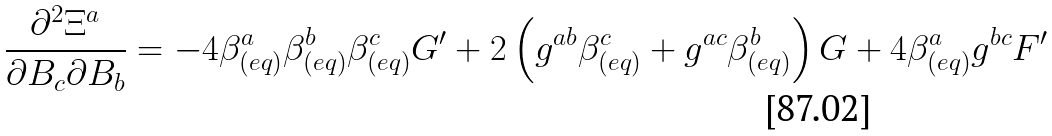<formula> <loc_0><loc_0><loc_500><loc_500>\frac { \partial ^ { 2 } \Xi ^ { a } } { \partial B _ { c } \partial B _ { b } } = - 4 \beta _ { ( e q ) } ^ { a } \beta _ { ( e q ) } ^ { b } \beta _ { ( e q ) } ^ { c } G ^ { \prime } + 2 \left ( g ^ { a b } \beta _ { ( e q ) } ^ { c } + g ^ { a c } \beta _ { ( e q ) } ^ { b } \right ) G + 4 \beta _ { ( e q ) } ^ { a } g ^ { b c } F ^ { \prime }</formula> 